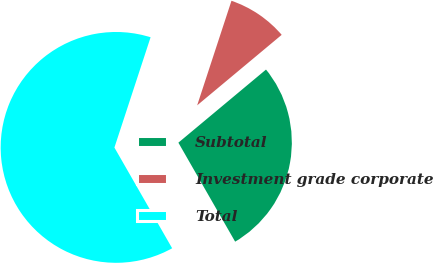Convert chart. <chart><loc_0><loc_0><loc_500><loc_500><pie_chart><fcel>Subtotal<fcel>Investment grade corporate<fcel>Total<nl><fcel>27.78%<fcel>8.89%<fcel>63.33%<nl></chart> 